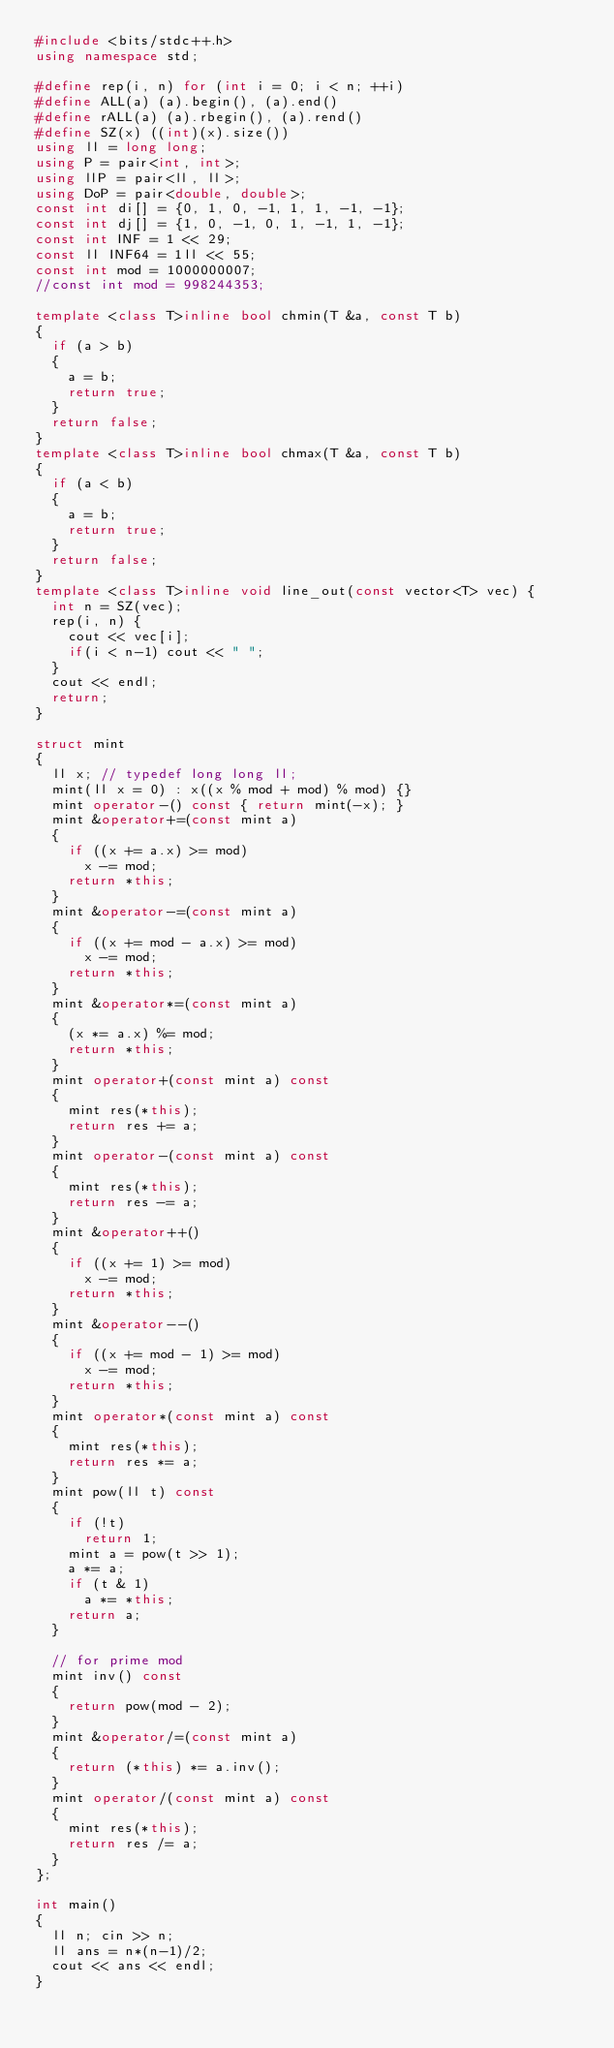Convert code to text. <code><loc_0><loc_0><loc_500><loc_500><_C++_>#include <bits/stdc++.h>
using namespace std;

#define rep(i, n) for (int i = 0; i < n; ++i)
#define ALL(a) (a).begin(), (a).end()
#define rALL(a) (a).rbegin(), (a).rend()
#define SZ(x) ((int)(x).size())
using ll = long long;
using P = pair<int, int>;
using llP = pair<ll, ll>;
using DoP = pair<double, double>;
const int di[] = {0, 1, 0, -1, 1, 1, -1, -1};
const int dj[] = {1, 0, -1, 0, 1, -1, 1, -1};
const int INF = 1 << 29;
const ll INF64 = 1ll << 55;
const int mod = 1000000007;
//const int mod = 998244353;

template <class T>inline bool chmin(T &a, const T b)
{
  if (a > b)
  {
    a = b;
    return true;
  }
  return false;
}
template <class T>inline bool chmax(T &a, const T b)
{
  if (a < b)
  {
    a = b;
    return true;
  }
  return false;
}
template <class T>inline void line_out(const vector<T> vec) {
  int n = SZ(vec);
  rep(i, n) {
    cout << vec[i];
    if(i < n-1) cout << " ";
  }
  cout << endl;
  return;
}

struct mint
{
  ll x; // typedef long long ll;
  mint(ll x = 0) : x((x % mod + mod) % mod) {}
  mint operator-() const { return mint(-x); }
  mint &operator+=(const mint a)
  {
    if ((x += a.x) >= mod)
      x -= mod;
    return *this;
  }
  mint &operator-=(const mint a)
  {
    if ((x += mod - a.x) >= mod)
      x -= mod;
    return *this;
  }
  mint &operator*=(const mint a)
  {
    (x *= a.x) %= mod;
    return *this;
  }
  mint operator+(const mint a) const
  {
    mint res(*this);
    return res += a;
  }
  mint operator-(const mint a) const
  {
    mint res(*this);
    return res -= a;
  }
  mint &operator++()
  {
    if ((x += 1) >= mod)
      x -= mod;
    return *this;
  }
  mint &operator--()
  {
    if ((x += mod - 1) >= mod)
      x -= mod;
    return *this;
  }
  mint operator*(const mint a) const
  {
    mint res(*this);
    return res *= a;
  }
  mint pow(ll t) const
  {
    if (!t)
      return 1;
    mint a = pow(t >> 1);
    a *= a;
    if (t & 1)
      a *= *this;
    return a;
  }

  // for prime mod
  mint inv() const
  {
    return pow(mod - 2);
  }
  mint &operator/=(const mint a)
  {
    return (*this) *= a.inv();
  }
  mint operator/(const mint a) const
  {
    mint res(*this);
    return res /= a;
  }
};

int main()
{
  ll n; cin >> n;
  ll ans = n*(n-1)/2;
  cout << ans << endl;
}</code> 